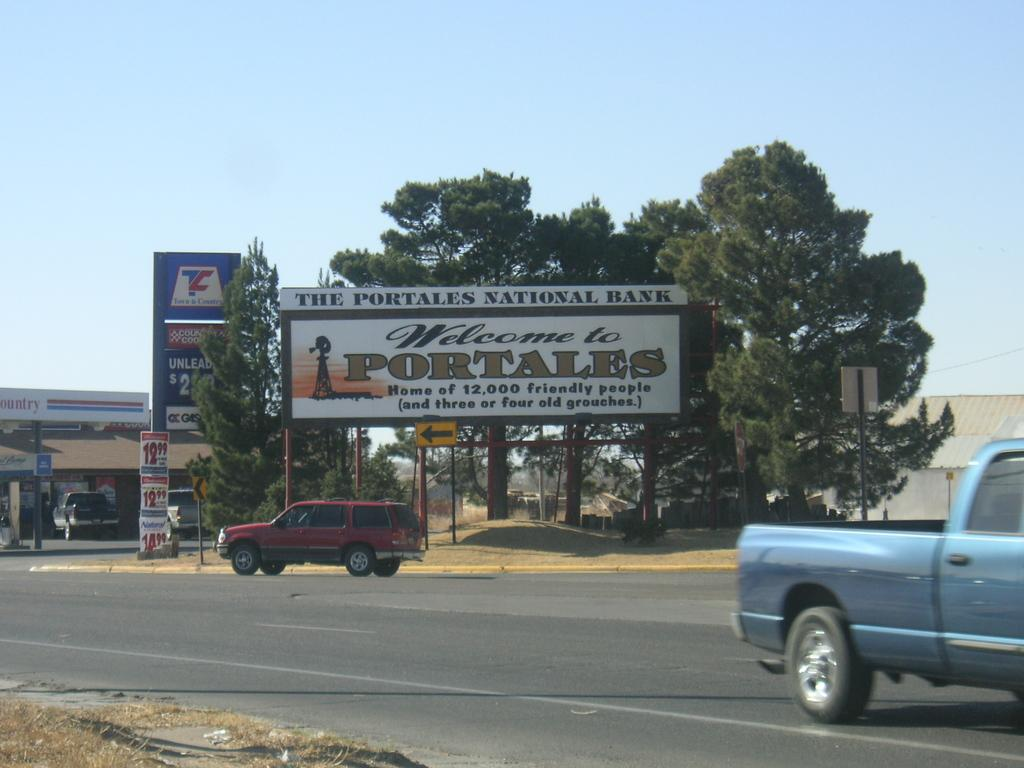What can be seen on the road in the image? There are vehicles on the road in the image. What type of natural elements can be seen in the background of the image? There are trees in the background of the image. What man-made structures can be seen in the background of the image? There are poles, hoardings, a sign board, posters, and houses in the background of the image. What is visible at the top of the image? The sky is visible at the top of the image. Where can the dirt be seen in the image? There is no dirt visible in the image. What type of creature can be seen slithering on the road in the image? There are no snakes or any other creatures visible in the image; only vehicles, trees, poles, hoardings, a sign board, posters, houses, and the sky are present. 